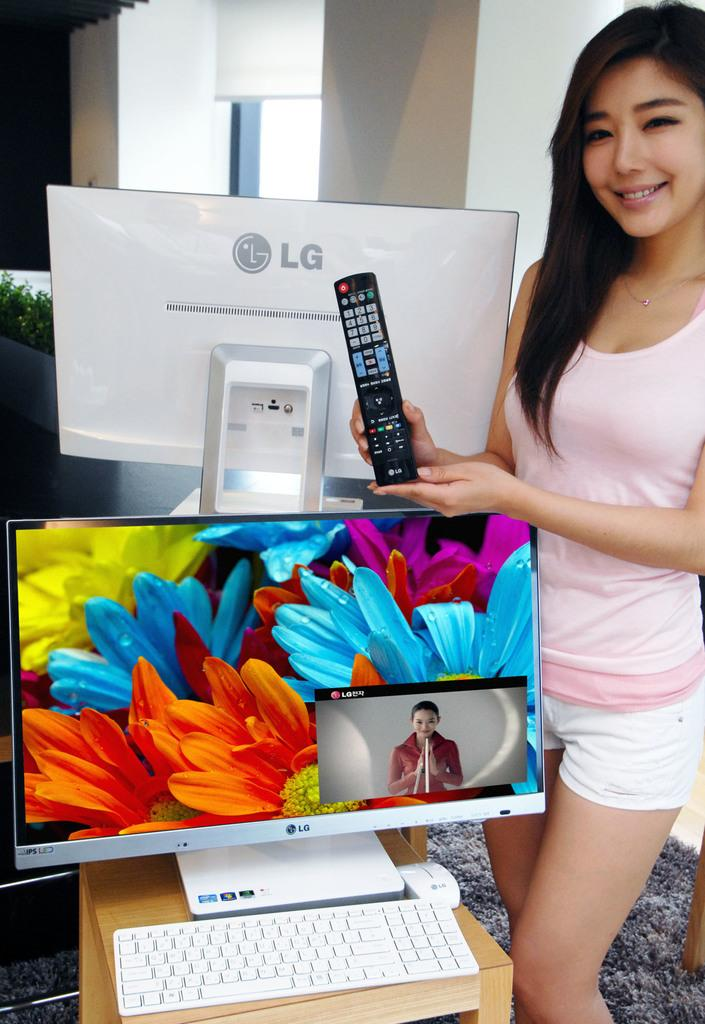<image>
Relay a brief, clear account of the picture shown. Woman holding a remote controller for the brand LG. 